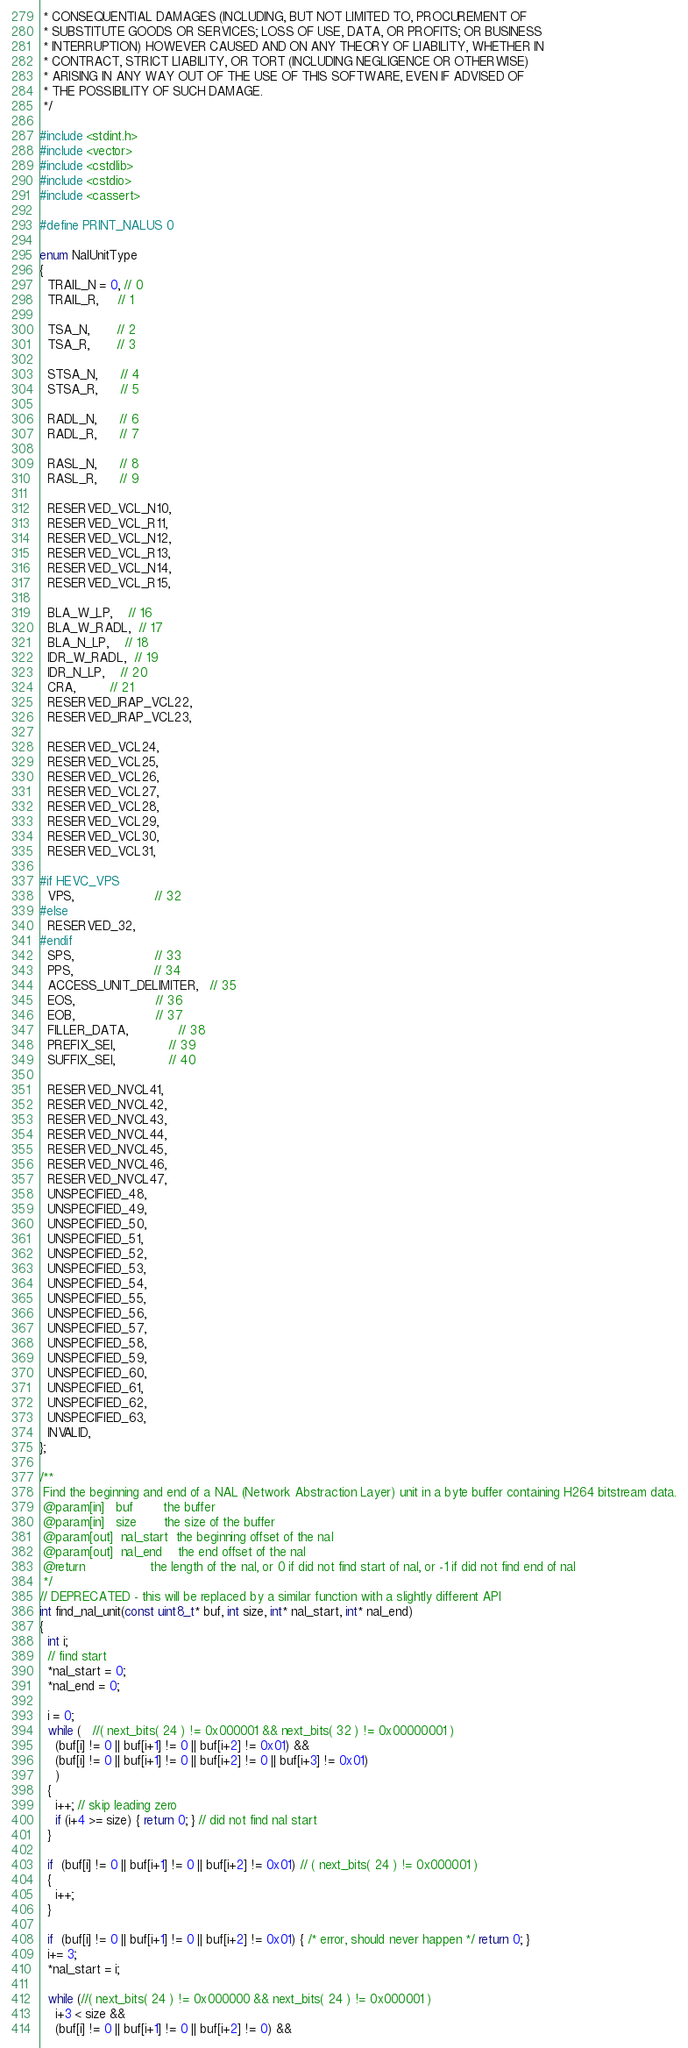<code> <loc_0><loc_0><loc_500><loc_500><_C++_> * CONSEQUENTIAL DAMAGES (INCLUDING, BUT NOT LIMITED TO, PROCUREMENT OF
 * SUBSTITUTE GOODS OR SERVICES; LOSS OF USE, DATA, OR PROFITS; OR BUSINESS
 * INTERRUPTION) HOWEVER CAUSED AND ON ANY THEORY OF LIABILITY, WHETHER IN
 * CONTRACT, STRICT LIABILITY, OR TORT (INCLUDING NEGLIGENCE OR OTHERWISE)
 * ARISING IN ANY WAY OUT OF THE USE OF THIS SOFTWARE, EVEN IF ADVISED OF
 * THE POSSIBILITY OF SUCH DAMAGE.
 */

#include <stdint.h>
#include <vector>
#include <cstdlib>
#include <cstdio>
#include <cassert>

#define PRINT_NALUS 0

enum NalUnitType
{
  TRAIL_N = 0, // 0
  TRAIL_R,     // 1

  TSA_N,       // 2
  TSA_R,       // 3

  STSA_N,      // 4
  STSA_R,      // 5

  RADL_N,      // 6
  RADL_R,      // 7

  RASL_N,      // 8
  RASL_R,      // 9

  RESERVED_VCL_N10,
  RESERVED_VCL_R11,
  RESERVED_VCL_N12,
  RESERVED_VCL_R13,
  RESERVED_VCL_N14,
  RESERVED_VCL_R15,

  BLA_W_LP,    // 16
  BLA_W_RADL,  // 17
  BLA_N_LP,    // 18
  IDR_W_RADL,  // 19
  IDR_N_LP,    // 20
  CRA,         // 21
  RESERVED_IRAP_VCL22,
  RESERVED_IRAP_VCL23,

  RESERVED_VCL24,
  RESERVED_VCL25,
  RESERVED_VCL26,
  RESERVED_VCL27,
  RESERVED_VCL28,
  RESERVED_VCL29,
  RESERVED_VCL30,
  RESERVED_VCL31,

#if HEVC_VPS
  VPS,                     // 32
#else
  RESERVED_32,
#endif
  SPS,                     // 33
  PPS,                     // 34
  ACCESS_UNIT_DELIMITER,   // 35
  EOS,                     // 36
  EOB,                     // 37
  FILLER_DATA,             // 38
  PREFIX_SEI,              // 39
  SUFFIX_SEI,              // 40

  RESERVED_NVCL41,
  RESERVED_NVCL42,
  RESERVED_NVCL43,
  RESERVED_NVCL44,
  RESERVED_NVCL45,
  RESERVED_NVCL46,
  RESERVED_NVCL47,
  UNSPECIFIED_48,
  UNSPECIFIED_49,
  UNSPECIFIED_50,
  UNSPECIFIED_51,
  UNSPECIFIED_52,
  UNSPECIFIED_53,
  UNSPECIFIED_54,
  UNSPECIFIED_55,
  UNSPECIFIED_56,
  UNSPECIFIED_57,
  UNSPECIFIED_58,
  UNSPECIFIED_59,
  UNSPECIFIED_60,
  UNSPECIFIED_61,
  UNSPECIFIED_62,
  UNSPECIFIED_63,
  INVALID,
};

/**
 Find the beginning and end of a NAL (Network Abstraction Layer) unit in a byte buffer containing H264 bitstream data.
 @param[in]   buf        the buffer
 @param[in]   size       the size of the buffer
 @param[out]  nal_start  the beginning offset of the nal
 @param[out]  nal_end    the end offset of the nal
 @return                 the length of the nal, or 0 if did not find start of nal, or -1 if did not find end of nal
 */
// DEPRECATED - this will be replaced by a similar function with a slightly different API
int find_nal_unit(const uint8_t* buf, int size, int* nal_start, int* nal_end)
{
  int i;
  // find start
  *nal_start = 0;
  *nal_end = 0;

  i = 0;
  while (   //( next_bits( 24 ) != 0x000001 && next_bits( 32 ) != 0x00000001 )
    (buf[i] != 0 || buf[i+1] != 0 || buf[i+2] != 0x01) &&
    (buf[i] != 0 || buf[i+1] != 0 || buf[i+2] != 0 || buf[i+3] != 0x01)
    )
  {
    i++; // skip leading zero
    if (i+4 >= size) { return 0; } // did not find nal start
  }

  if  (buf[i] != 0 || buf[i+1] != 0 || buf[i+2] != 0x01) // ( next_bits( 24 ) != 0x000001 )
  {
    i++;
  }

  if  (buf[i] != 0 || buf[i+1] != 0 || buf[i+2] != 0x01) { /* error, should never happen */ return 0; }
  i+= 3;
  *nal_start = i;

  while (//( next_bits( 24 ) != 0x000000 && next_bits( 24 ) != 0x000001 )
    i+3 < size &&
    (buf[i] != 0 || buf[i+1] != 0 || buf[i+2] != 0) &&</code> 